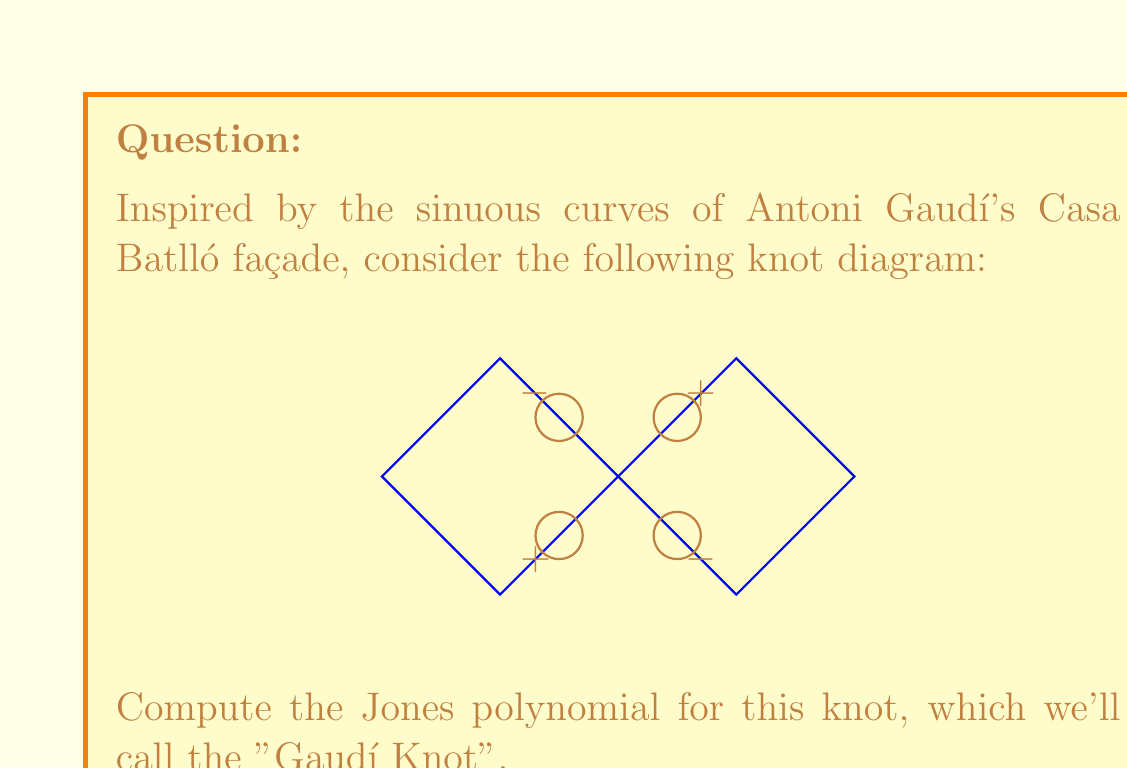Help me with this question. To compute the Jones polynomial for the Gaudí Knot, we'll follow these steps:

1) First, we need to determine the writhe of the knot. The writhe is the sum of the signs of all crossings. From the diagram:
   $w = (+1) + (-1) + (-1) + (+1) = 0$

2) Next, we'll use the Kauffman bracket polynomial. We need to consider all possible state diagrams by smoothing each crossing in two ways:
   A-smoothing (0) and B-smoothing (1).

3) There are 4 crossings, so we have $2^4 = 16$ possible states. Let's represent each state as a binary number:

   0000: 2 circles, all A-smoothings
   0001, 0010, 0100, 1000: 1 circle, three A and one B
   0011, 0101, 0110, 1001, 1010, 1100: 2 circles, two A and two B
   0111, 1011, 1101, 1110: 1 circle, one A and three B
   1111: 2 circles, all B-smoothings

4) The Kauffman bracket polynomial is:

   $$\langle G \rangle = A^4 \cdot 2 + A^2 \cdot 4 + 6 + A^{-2} \cdot 4 + A^{-4} \cdot 2$$

5) Simplify:

   $$\langle G \rangle = 2A^4 + 4A^2 + 6 + 4A^{-2} + 2A^{-4}$$

6) The Jones polynomial is related to the Kauffman bracket by:

   $$V_G(t) = (-A^3)^{-w} \cdot \langle G \rangle |_{A = t^{-1/4}}$$

7) Since the writhe is 0, we have:

   $$V_G(t) = (2t^{-1} + 4t^{-1/2} + 6 + 4t^{1/2} + 2t)$$

8) This can be written in standard form as:

   $$V_G(t) = 2t^{-1} + 4t^{-1/2} + 6 + 4t^{1/2} + 2t$$
Answer: $V_G(t) = 2t^{-1} + 4t^{-1/2} + 6 + 4t^{1/2} + 2t$ 